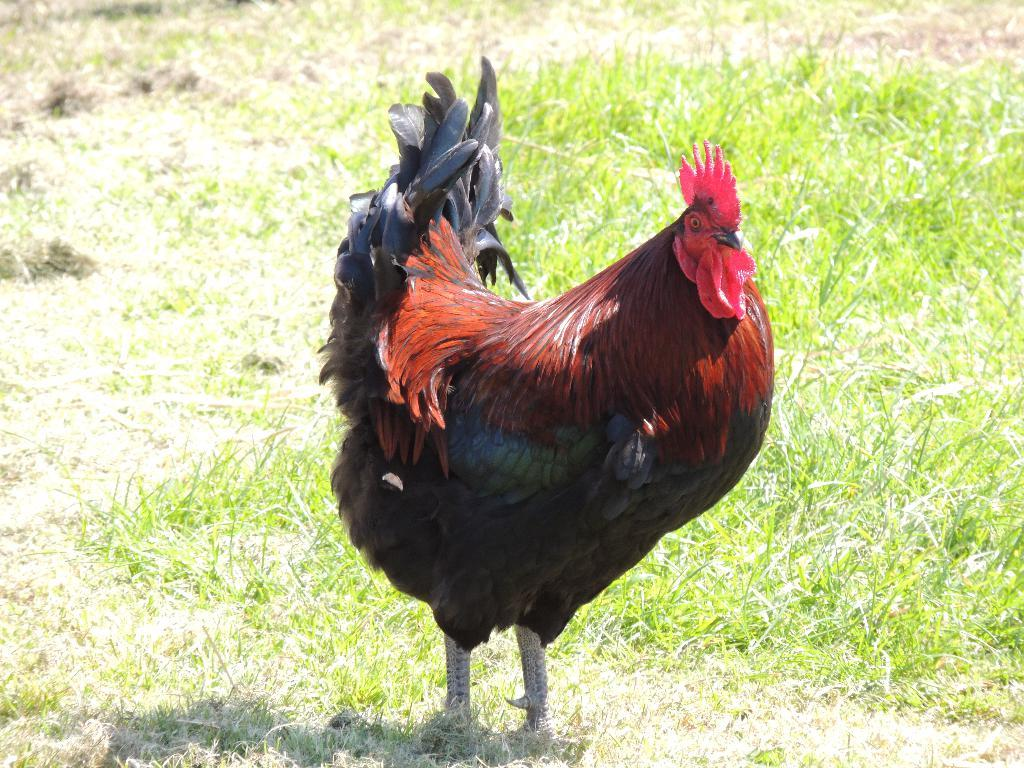What animal is in the picture? There is a cock in the picture. What colors can be seen on the cock? The cock is in brown and black color. What type of terrain is visible at the bottom of the image? There is grass visible at the bottom of the image. What is the weather like on the day the picture was taken? It is a sunny day. How does the rat use the brake in the image? There is no rat or brake present in the image. What force is applied to the cock in the image? There is no force being applied to the cock in the image; it is standing still. 